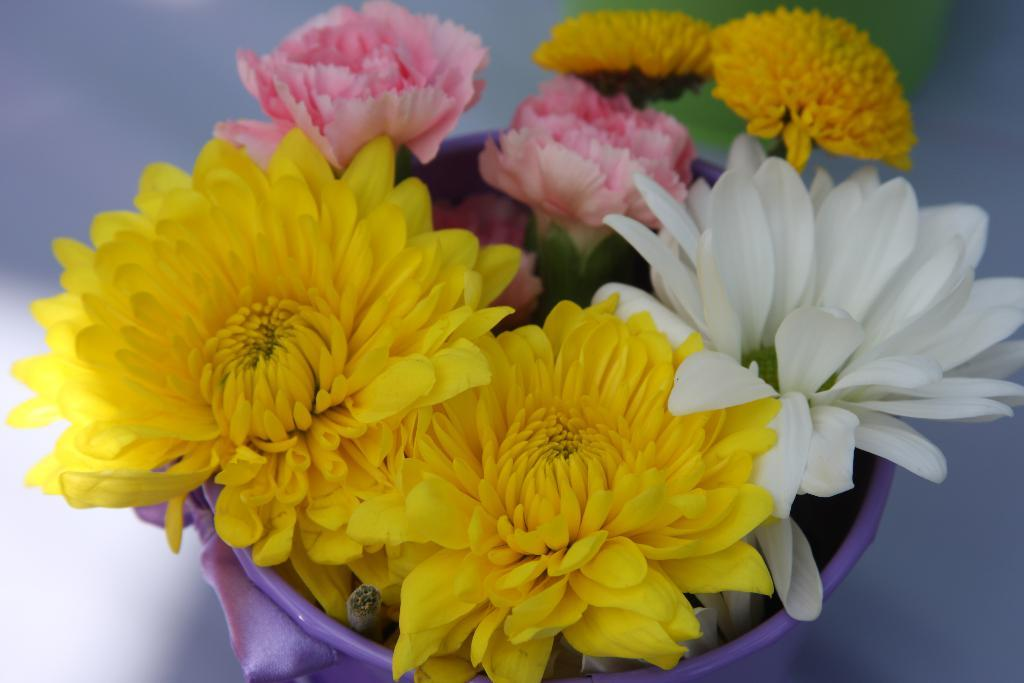What type of plants can be seen in the image? There are flowers in the image. Where are the flowers located? The flowers are inside a flower pot. What is the position of the flower pot in the image? The flower pot is in the center of the image. How would you describe the background of the image? The background of the image is blurry. What type of sound can be heard coming from the cactus in the image? There is no cactus present in the image, and therefore no sound can be heard coming from it. 